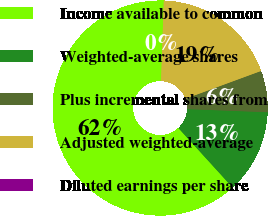Convert chart to OTSL. <chart><loc_0><loc_0><loc_500><loc_500><pie_chart><fcel>Income available to common<fcel>Weighted-average shares<fcel>Plus incremental shares from<fcel>Adjusted weighted-average<fcel>Diluted earnings per share<nl><fcel>62.31%<fcel>12.62%<fcel>6.23%<fcel>18.85%<fcel>0.0%<nl></chart> 